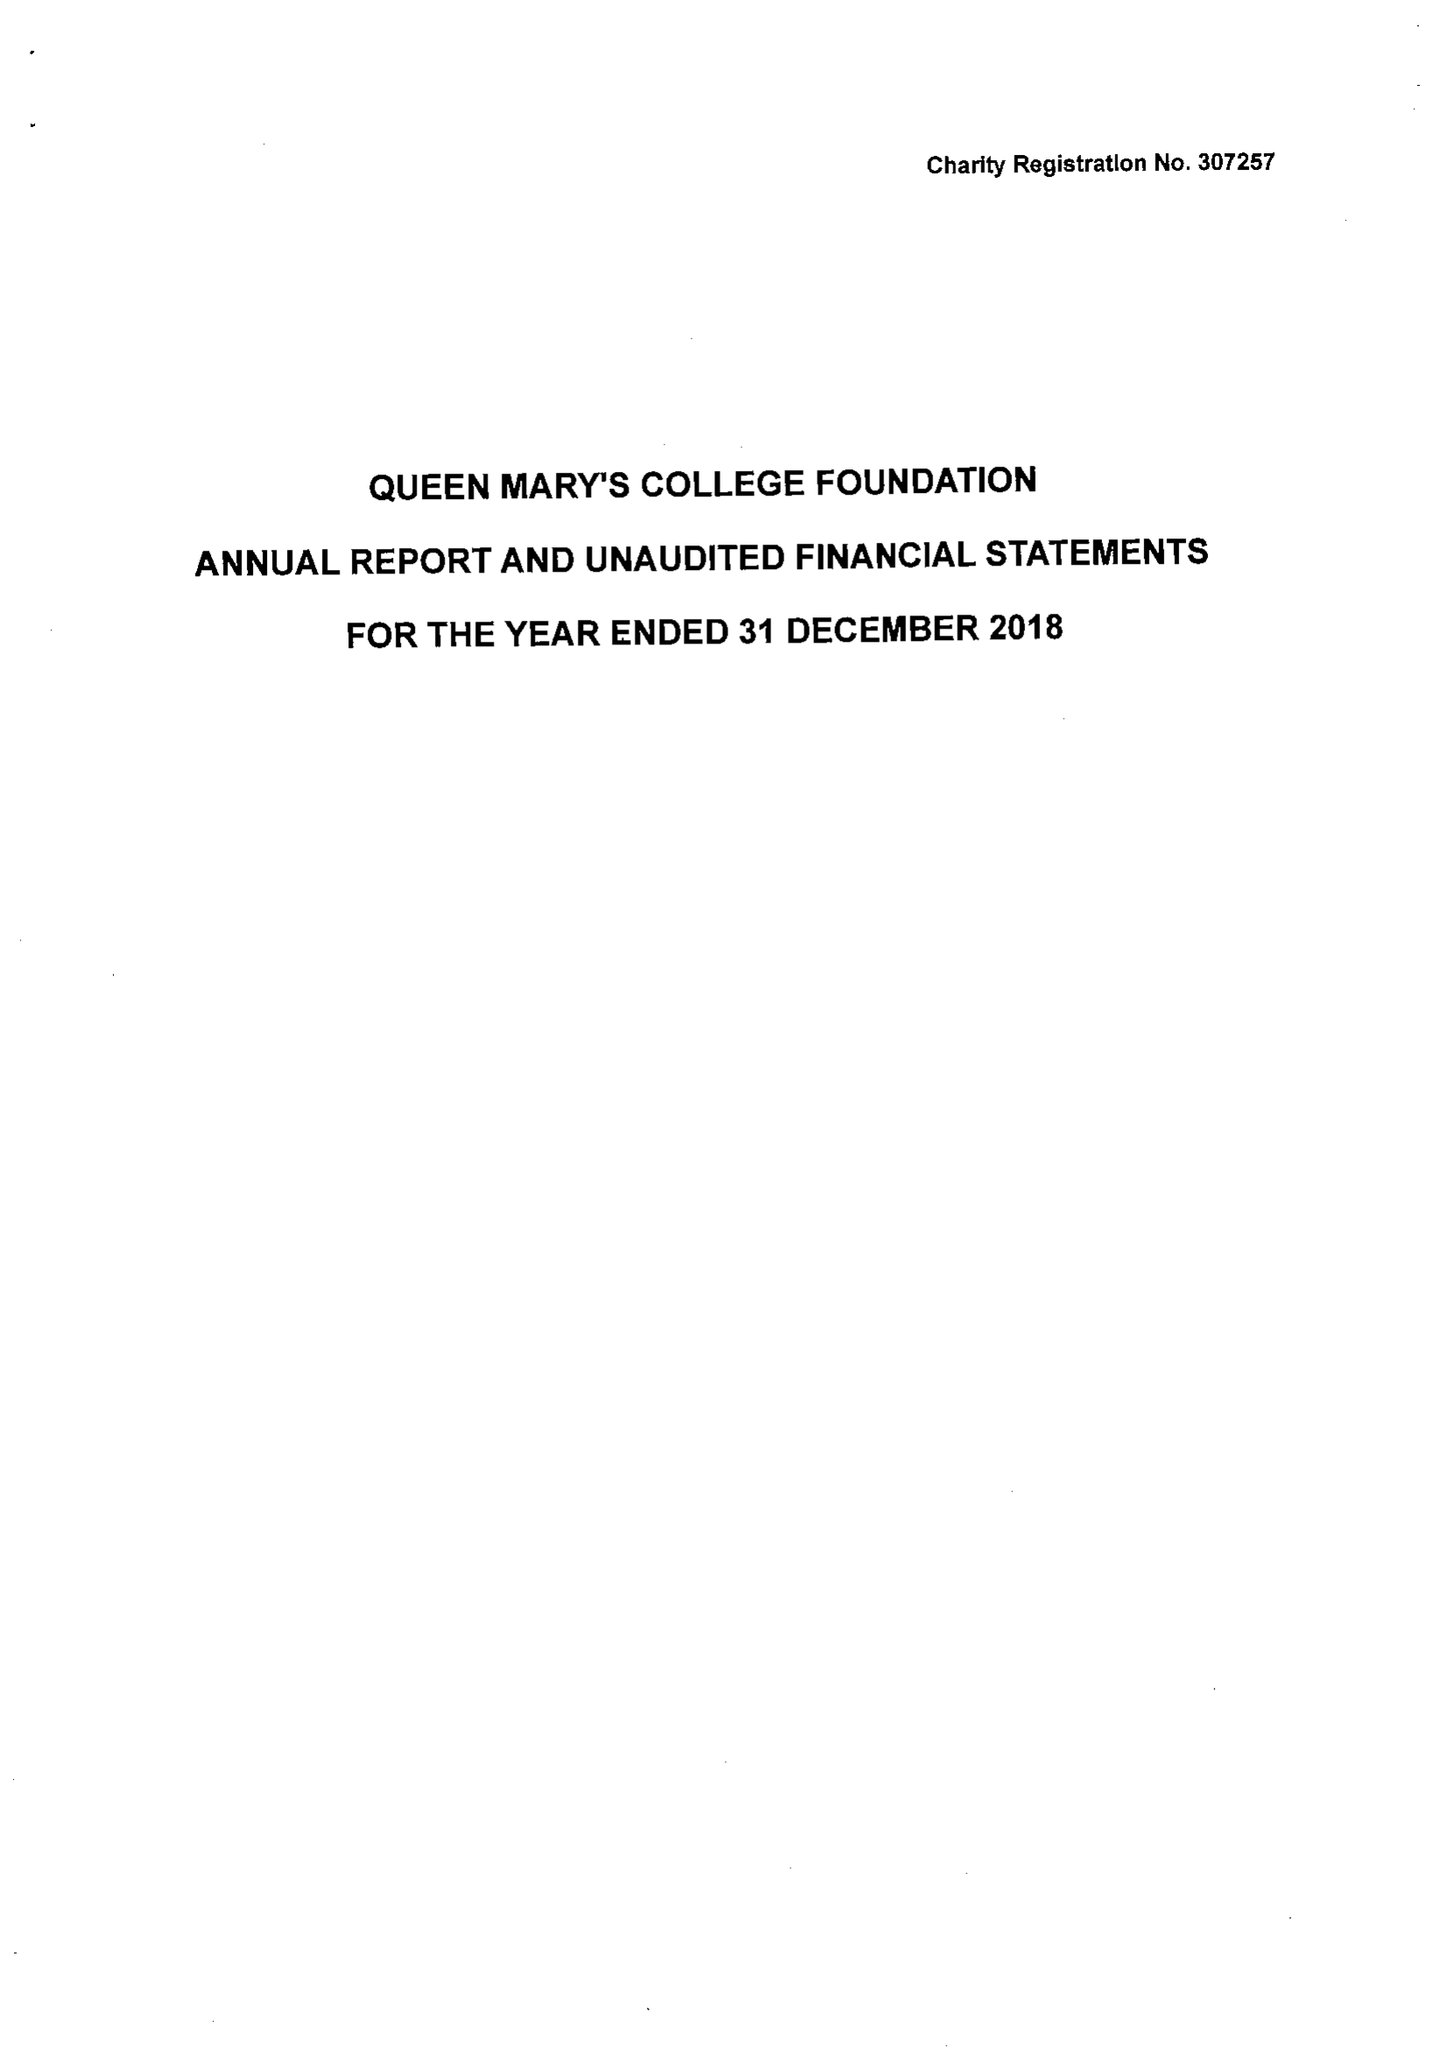What is the value for the address__street_line?
Answer the question using a single word or phrase. CLIDDESDEN ROAD 